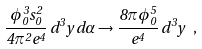Convert formula to latex. <formula><loc_0><loc_0><loc_500><loc_500>\frac { \phi _ { 0 } ^ { 3 } s _ { 0 } ^ { 2 } } { 4 \pi ^ { 2 } e ^ { 4 } } \, d ^ { 3 } y \, d \alpha \to \frac { 8 \pi \phi _ { 0 } ^ { 5 } } { e ^ { 4 } } \, d ^ { 3 } y \ ,</formula> 